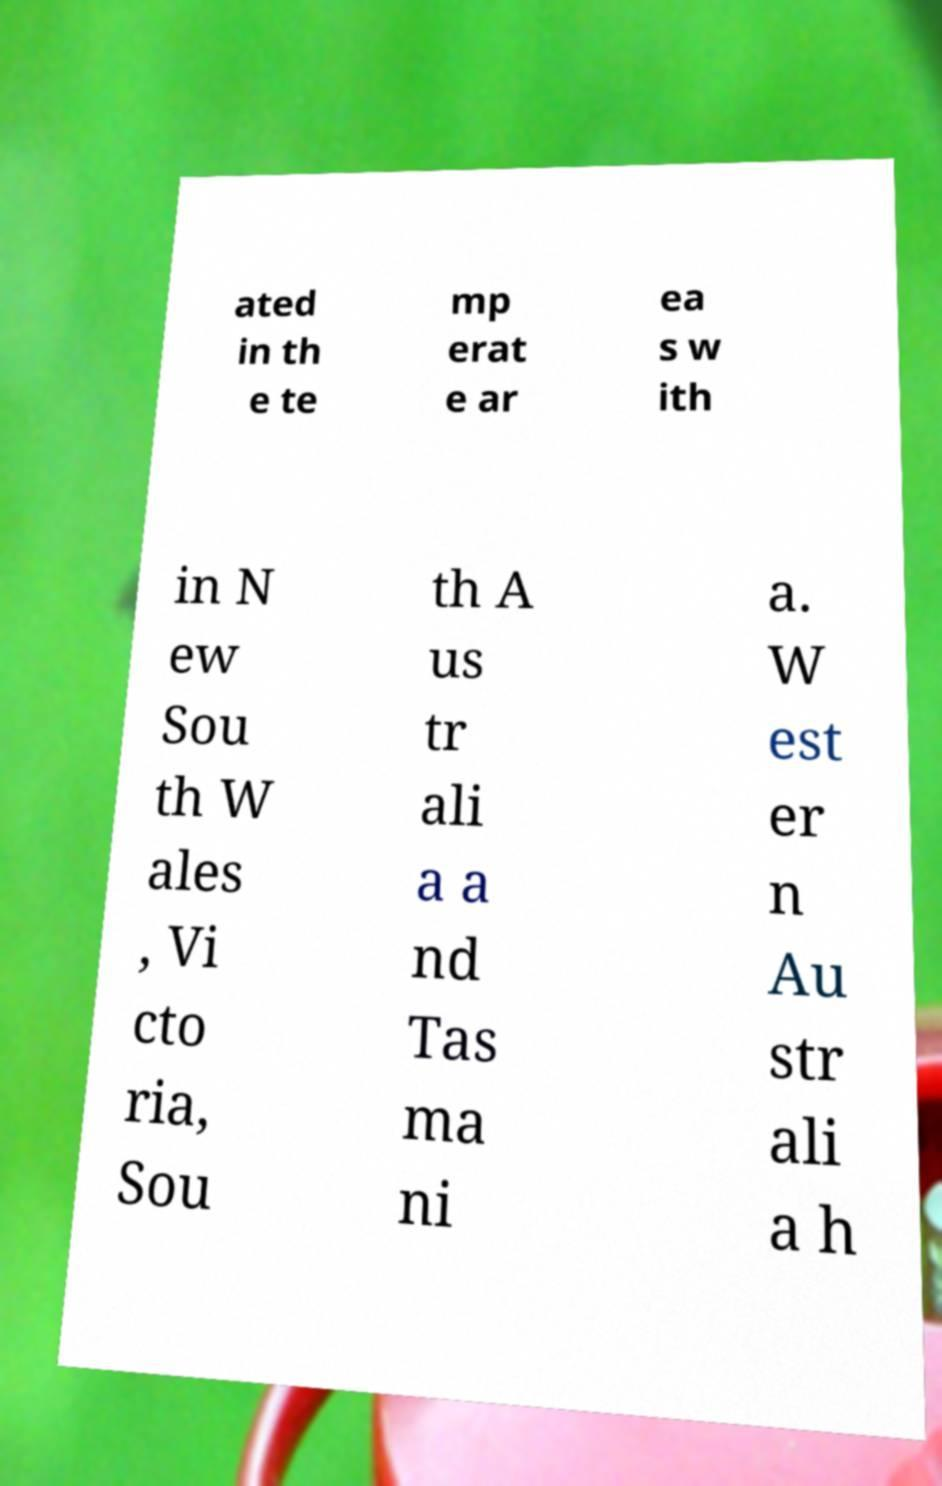Please identify and transcribe the text found in this image. ated in th e te mp erat e ar ea s w ith in N ew Sou th W ales , Vi cto ria, Sou th A us tr ali a a nd Tas ma ni a. W est er n Au str ali a h 